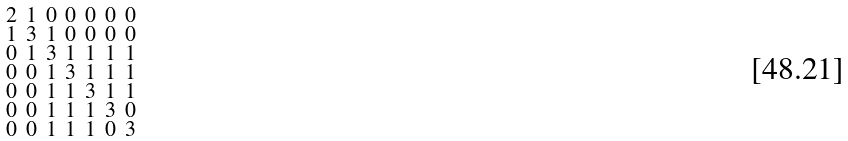Convert formula to latex. <formula><loc_0><loc_0><loc_500><loc_500>\begin{smallmatrix} 2 & 1 & 0 & 0 & 0 & 0 & 0 \\ 1 & 3 & 1 & 0 & 0 & 0 & 0 \\ 0 & 1 & 3 & 1 & 1 & 1 & 1 \\ 0 & 0 & 1 & 3 & 1 & 1 & 1 \\ 0 & 0 & 1 & 1 & 3 & 1 & 1 \\ 0 & 0 & 1 & 1 & 1 & 3 & 0 \\ 0 & 0 & 1 & 1 & 1 & 0 & 3 \end{smallmatrix}</formula> 